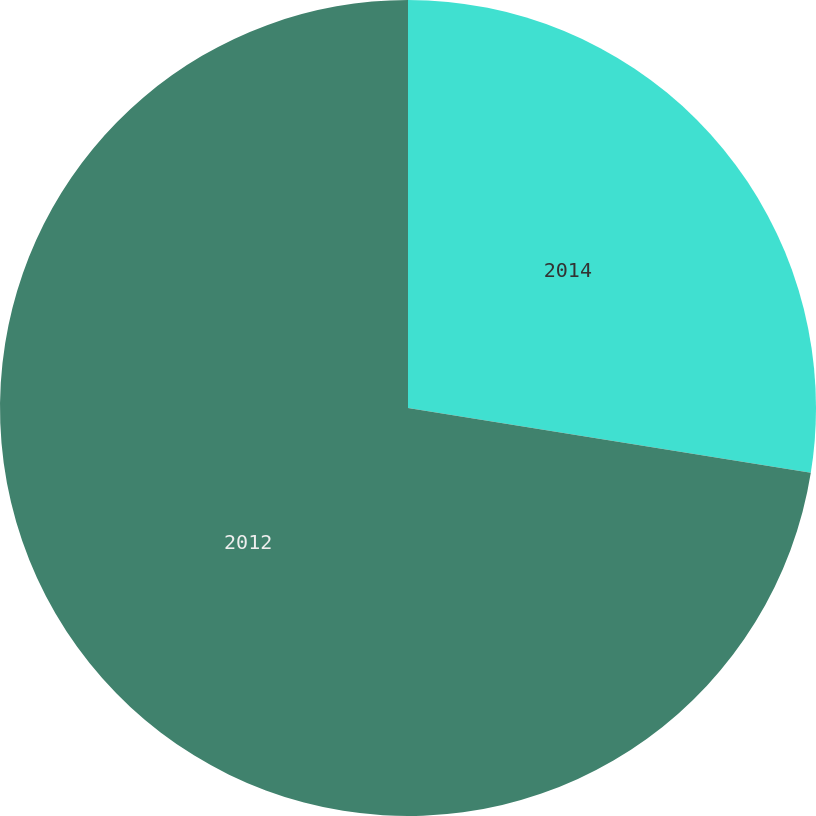Convert chart. <chart><loc_0><loc_0><loc_500><loc_500><pie_chart><fcel>2014<fcel>2012<nl><fcel>27.54%<fcel>72.46%<nl></chart> 